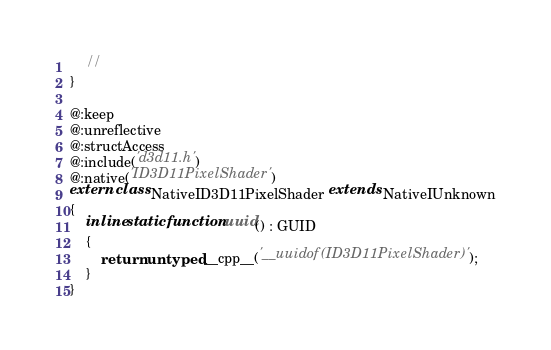<code> <loc_0><loc_0><loc_500><loc_500><_Haxe_>    //
}

@:keep
@:unreflective
@:structAccess
@:include('d3d11.h')
@:native('ID3D11PixelShader')
extern class NativeID3D11PixelShader extends NativeIUnknown
{
    inline static function uuid() : GUID
    {
        return untyped __cpp__('__uuidof(ID3D11PixelShader)');
    }
}
</code> 